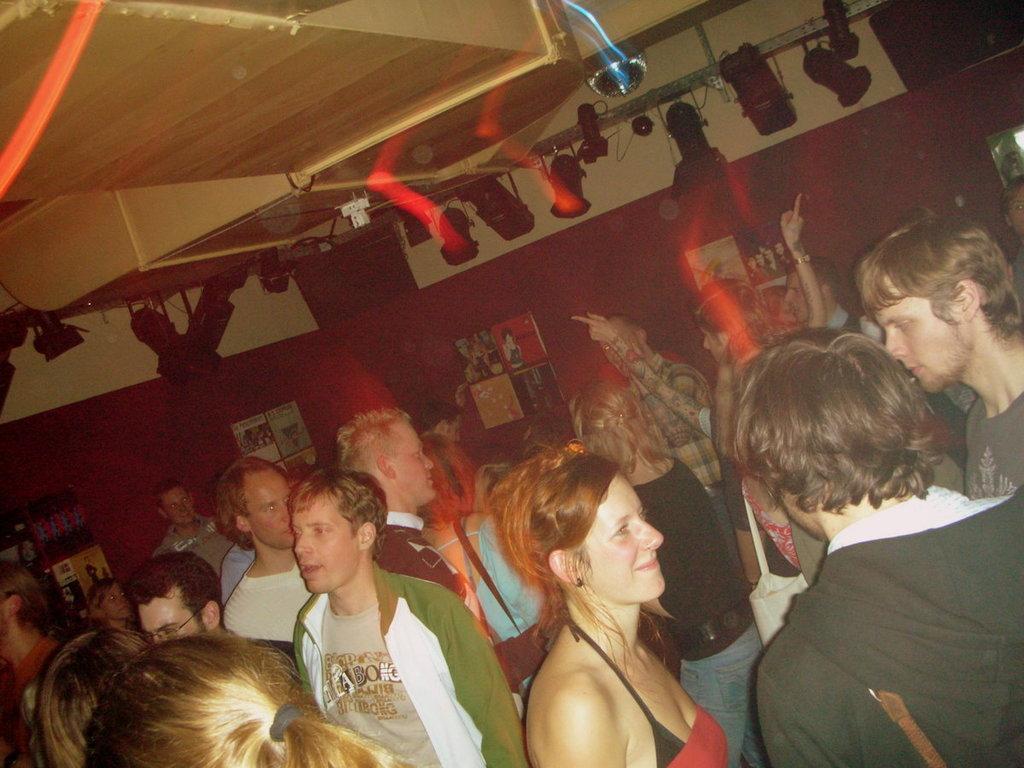In one or two sentences, can you explain what this image depicts? In this image there are a few people around them there are posters and photo frames on the wall and there are some objects, at the top of the image there are lamps and disco balls on the roof. 